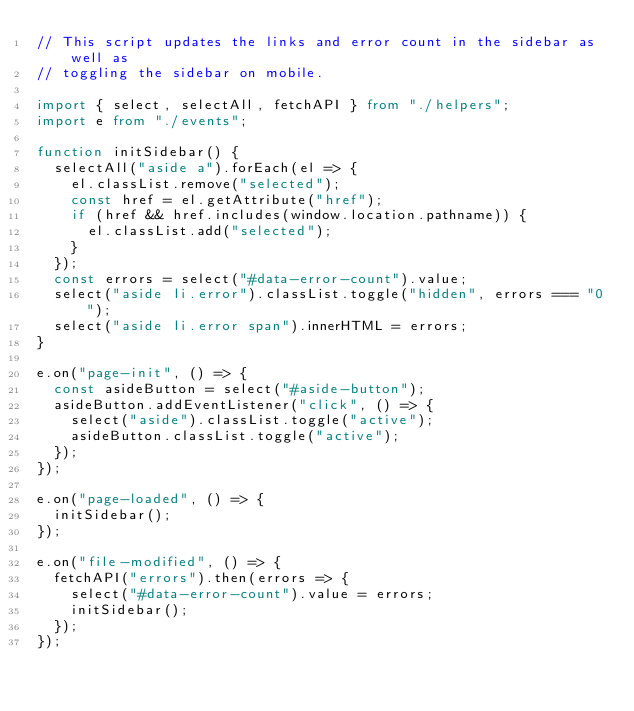<code> <loc_0><loc_0><loc_500><loc_500><_TypeScript_>// This script updates the links and error count in the sidebar as well as
// toggling the sidebar on mobile.

import { select, selectAll, fetchAPI } from "./helpers";
import e from "./events";

function initSidebar() {
  selectAll("aside a").forEach(el => {
    el.classList.remove("selected");
    const href = el.getAttribute("href");
    if (href && href.includes(window.location.pathname)) {
      el.classList.add("selected");
    }
  });
  const errors = select("#data-error-count").value;
  select("aside li.error").classList.toggle("hidden", errors === "0");
  select("aside li.error span").innerHTML = errors;
}

e.on("page-init", () => {
  const asideButton = select("#aside-button");
  asideButton.addEventListener("click", () => {
    select("aside").classList.toggle("active");
    asideButton.classList.toggle("active");
  });
});

e.on("page-loaded", () => {
  initSidebar();
});

e.on("file-modified", () => {
  fetchAPI("errors").then(errors => {
    select("#data-error-count").value = errors;
    initSidebar();
  });
});
</code> 